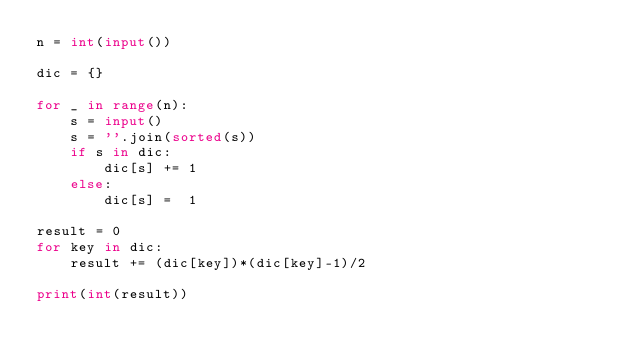Convert code to text. <code><loc_0><loc_0><loc_500><loc_500><_Python_>n = int(input())

dic = {}

for _ in range(n):
    s = input()
    s = ''.join(sorted(s))
    if s in dic:
        dic[s] += 1
    else:
        dic[s] =  1

result = 0
for key in dic:
    result += (dic[key])*(dic[key]-1)/2

print(int(result))
</code> 